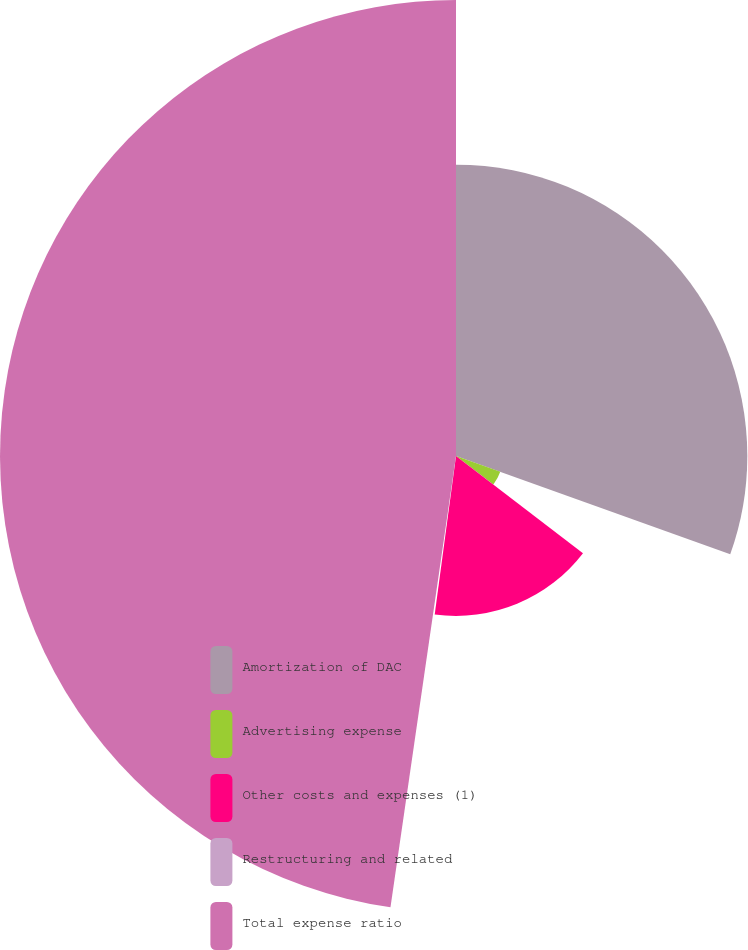<chart> <loc_0><loc_0><loc_500><loc_500><pie_chart><fcel>Amortization of DAC<fcel>Advertising expense<fcel>Other costs and expenses (1)<fcel>Restructuring and related<fcel>Total expense ratio<nl><fcel>30.48%<fcel>4.92%<fcel>16.73%<fcel>0.17%<fcel>47.71%<nl></chart> 